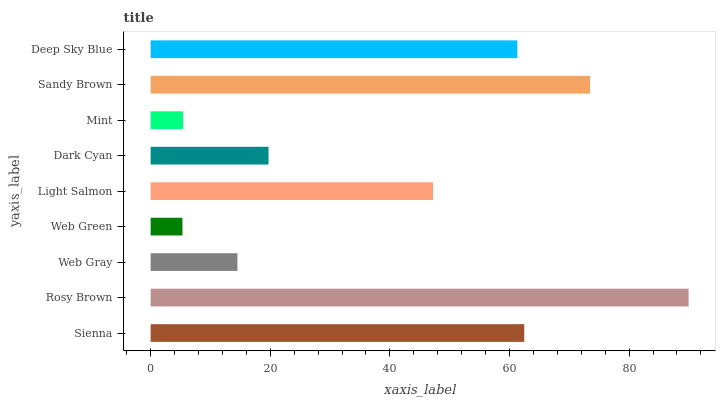Is Web Green the minimum?
Answer yes or no. Yes. Is Rosy Brown the maximum?
Answer yes or no. Yes. Is Web Gray the minimum?
Answer yes or no. No. Is Web Gray the maximum?
Answer yes or no. No. Is Rosy Brown greater than Web Gray?
Answer yes or no. Yes. Is Web Gray less than Rosy Brown?
Answer yes or no. Yes. Is Web Gray greater than Rosy Brown?
Answer yes or no. No. Is Rosy Brown less than Web Gray?
Answer yes or no. No. Is Light Salmon the high median?
Answer yes or no. Yes. Is Light Salmon the low median?
Answer yes or no. Yes. Is Mint the high median?
Answer yes or no. No. Is Dark Cyan the low median?
Answer yes or no. No. 